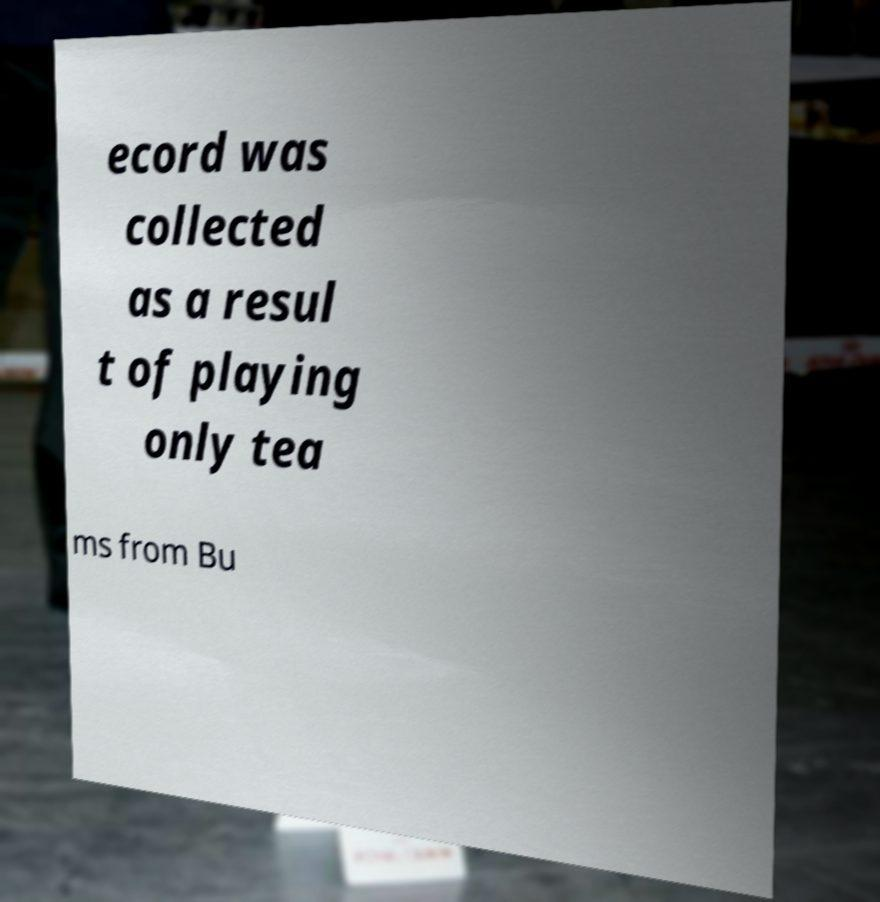Please read and relay the text visible in this image. What does it say? ecord was collected as a resul t of playing only tea ms from Bu 